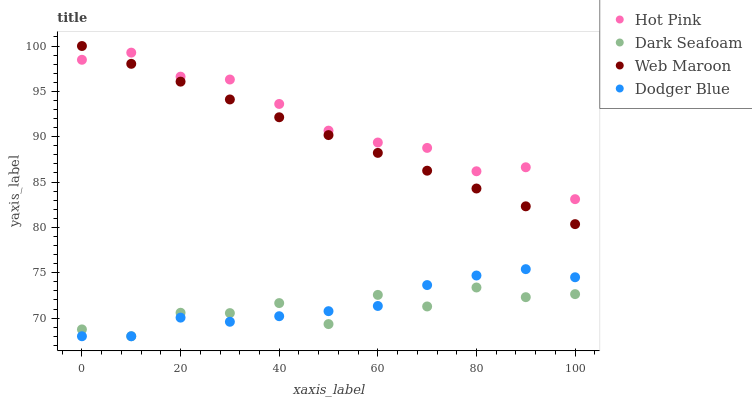Does Dark Seafoam have the minimum area under the curve?
Answer yes or no. Yes. Does Hot Pink have the maximum area under the curve?
Answer yes or no. Yes. Does Hot Pink have the minimum area under the curve?
Answer yes or no. No. Does Dark Seafoam have the maximum area under the curve?
Answer yes or no. No. Is Web Maroon the smoothest?
Answer yes or no. Yes. Is Dark Seafoam the roughest?
Answer yes or no. Yes. Is Hot Pink the smoothest?
Answer yes or no. No. Is Hot Pink the roughest?
Answer yes or no. No. Does Dodger Blue have the lowest value?
Answer yes or no. Yes. Does Hot Pink have the lowest value?
Answer yes or no. No. Does Web Maroon have the highest value?
Answer yes or no. Yes. Does Hot Pink have the highest value?
Answer yes or no. No. Is Dodger Blue less than Hot Pink?
Answer yes or no. Yes. Is Web Maroon greater than Dodger Blue?
Answer yes or no. Yes. Does Web Maroon intersect Hot Pink?
Answer yes or no. Yes. Is Web Maroon less than Hot Pink?
Answer yes or no. No. Is Web Maroon greater than Hot Pink?
Answer yes or no. No. Does Dodger Blue intersect Hot Pink?
Answer yes or no. No. 